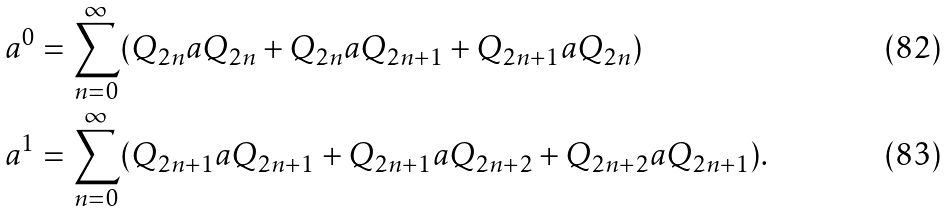<formula> <loc_0><loc_0><loc_500><loc_500>a ^ { 0 } & = \sum _ { n = 0 } ^ { \infty } ( Q _ { 2 n } a Q _ { 2 n } + Q _ { 2 n } a Q _ { 2 n + 1 } + Q _ { 2 n + 1 } a Q _ { 2 n } ) \\ a ^ { 1 } & = \sum _ { n = 0 } ^ { \infty } ( Q _ { 2 n + 1 } a Q _ { 2 n + 1 } + Q _ { 2 n + 1 } a Q _ { 2 n + 2 } + Q _ { 2 n + 2 } a Q _ { 2 n + 1 } ) .</formula> 